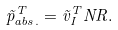<formula> <loc_0><loc_0><loc_500><loc_500>\vec { p } ^ { T } _ { a b s . } = \vec { v } _ { I } ^ { T } N R .</formula> 